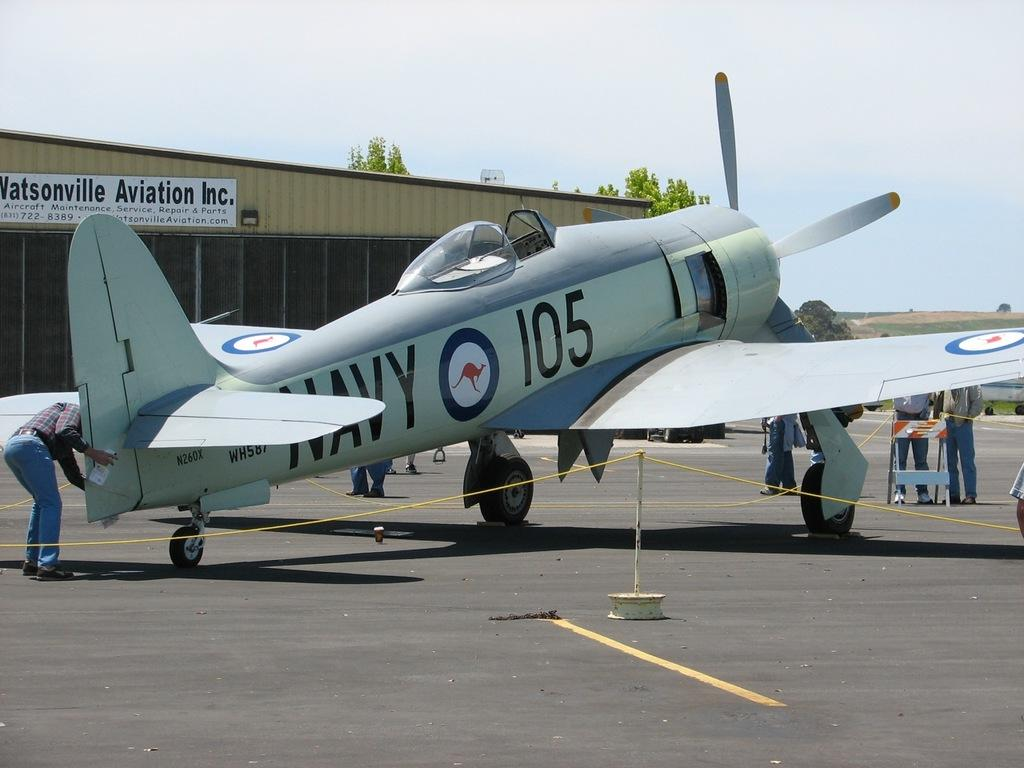Provide a one-sentence caption for the provided image. Navy 105 was getting inspected for the Watsonville Aviation Inc. 